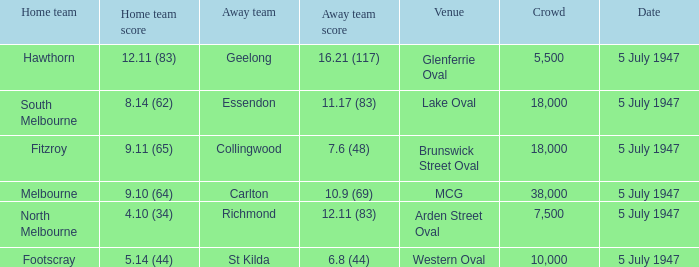8 (44)? Footscray. 